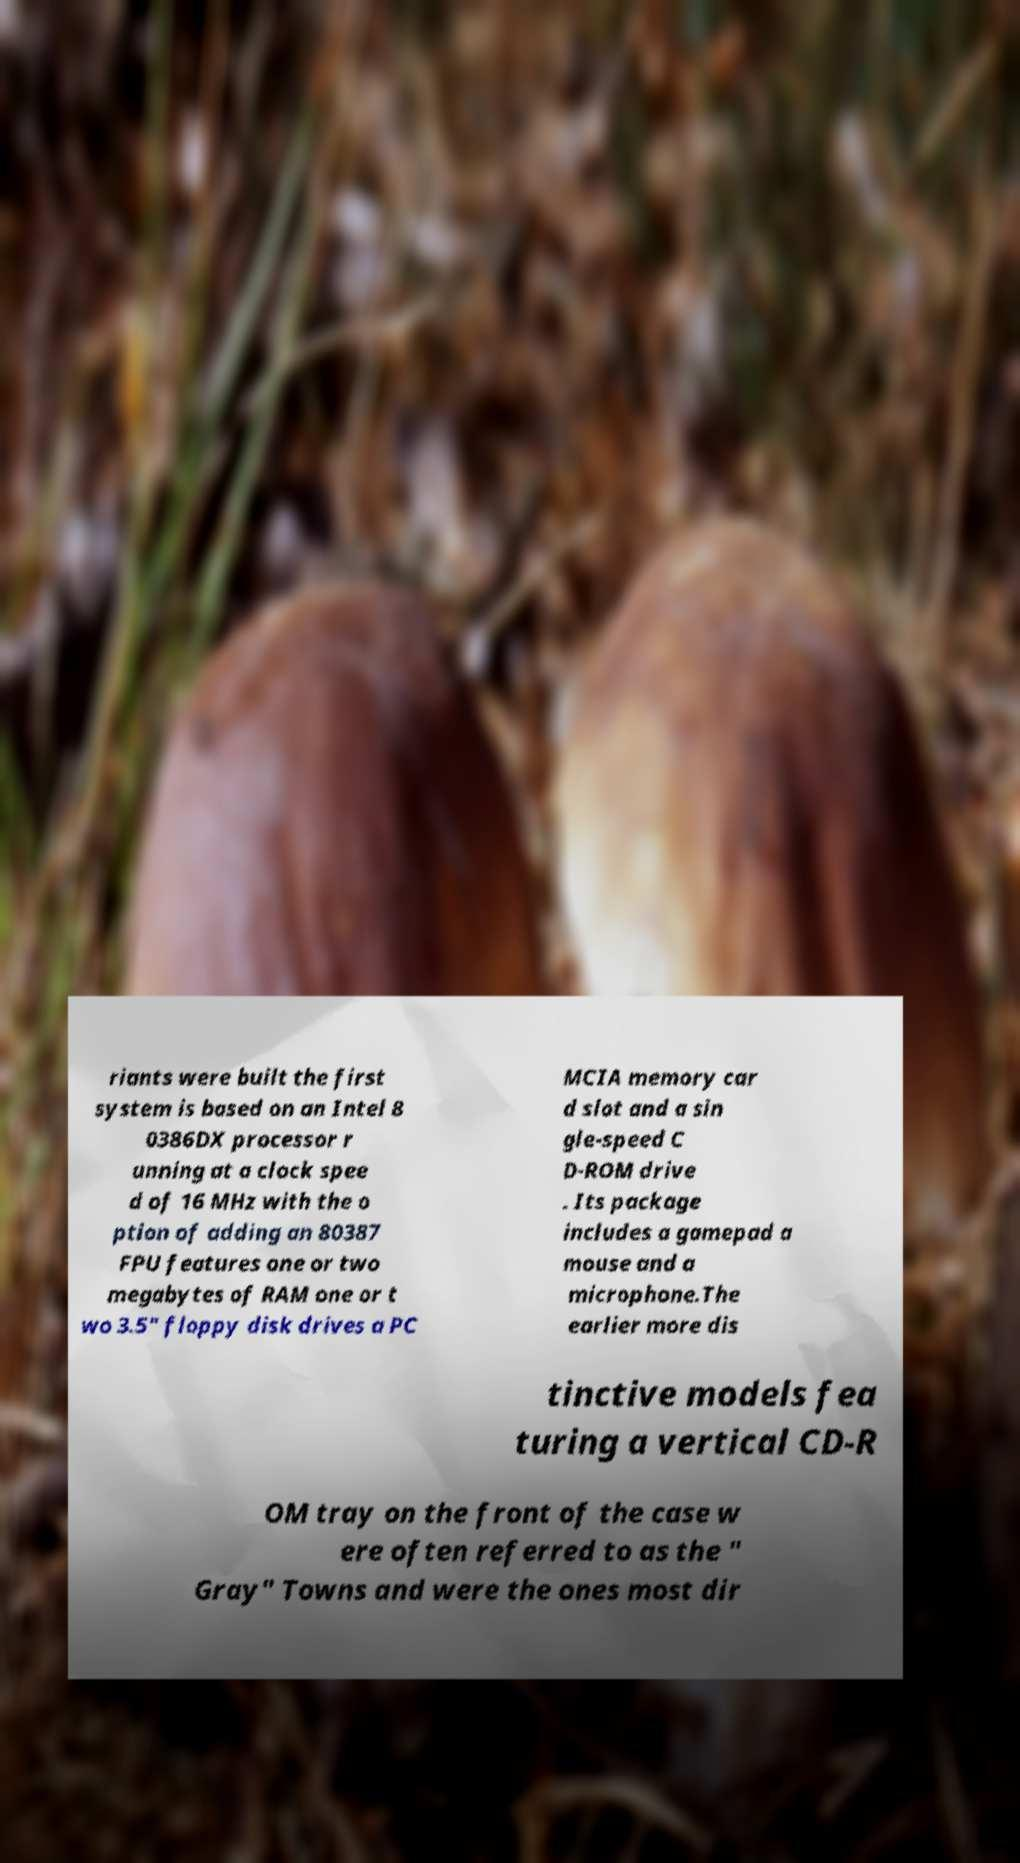Could you assist in decoding the text presented in this image and type it out clearly? riants were built the first system is based on an Intel 8 0386DX processor r unning at a clock spee d of 16 MHz with the o ption of adding an 80387 FPU features one or two megabytes of RAM one or t wo 3.5" floppy disk drives a PC MCIA memory car d slot and a sin gle-speed C D-ROM drive . Its package includes a gamepad a mouse and a microphone.The earlier more dis tinctive models fea turing a vertical CD-R OM tray on the front of the case w ere often referred to as the " Gray" Towns and were the ones most dir 